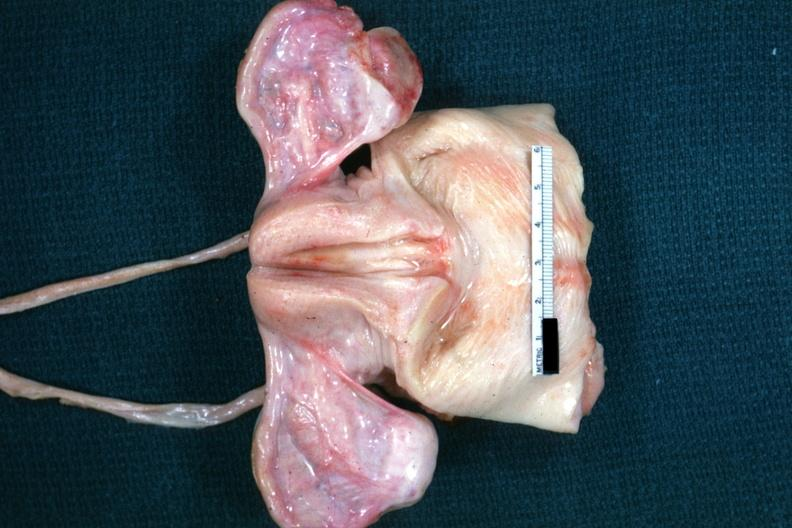re not truly normal ovaries non functional in this case of vacant sella but externally i can see nothing?
Answer the question using a single word or phrase. Yes 